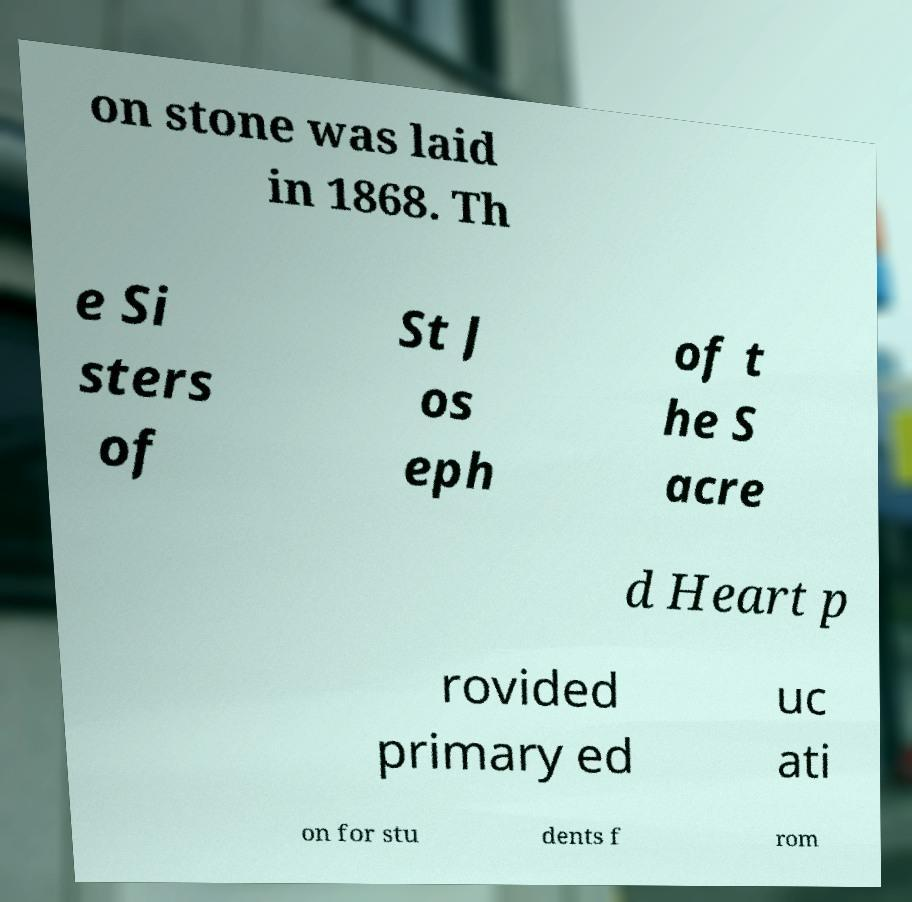Could you assist in decoding the text presented in this image and type it out clearly? on stone was laid in 1868. Th e Si sters of St J os eph of t he S acre d Heart p rovided primary ed uc ati on for stu dents f rom 